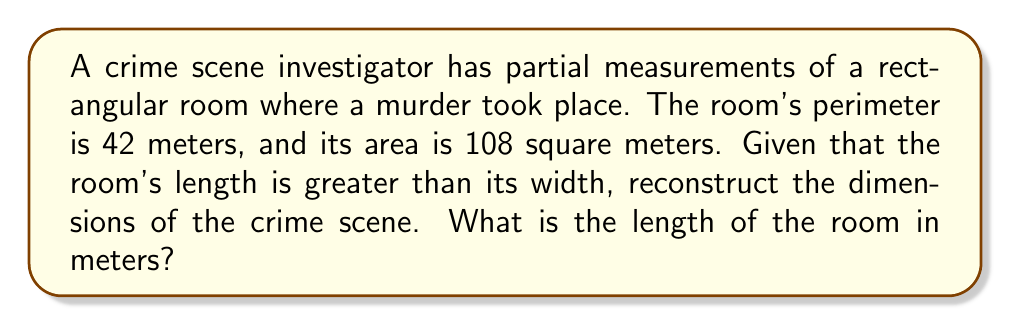Show me your answer to this math problem. Let's approach this step-by-step using the given information and the principles of inverse problem-solving:

1) Let $l$ be the length and $w$ be the width of the room.

2) Given that the perimeter is 42 meters:
   $$2l + 2w = 42$$
   $$l + w = 21$$ ... (Equation 1)

3) The area of the room is 108 square meters:
   $$lw = 108$$ ... (Equation 2)

4) From Equation 1, we can express $w$ in terms of $l$:
   $$w = 21 - l$$ ... (Equation 3)

5) Substituting Equation 3 into Equation 2:
   $$l(21 - l) = 108$$
   $$21l - l^2 = 108$$
   $$l^2 - 21l + 108 = 0$$

6) This is a quadratic equation. We can solve it using the quadratic formula:
   $$l = \frac{-b \pm \sqrt{b^2 - 4ac}}{2a}$$
   Where $a = 1$, $b = -21$, and $c = 108$

7) Solving:
   $$l = \frac{21 \pm \sqrt{441 - 432}}{2} = \frac{21 \pm 3}{2}$$

8) This gives us two solutions:
   $$l_1 = \frac{21 + 3}{2} = 12$$
   $$l_2 = \frac{21 - 3}{2} = 9$$

9) Since we're told that the length is greater than the width, we choose $l_1 = 12$.
Answer: 12 meters 